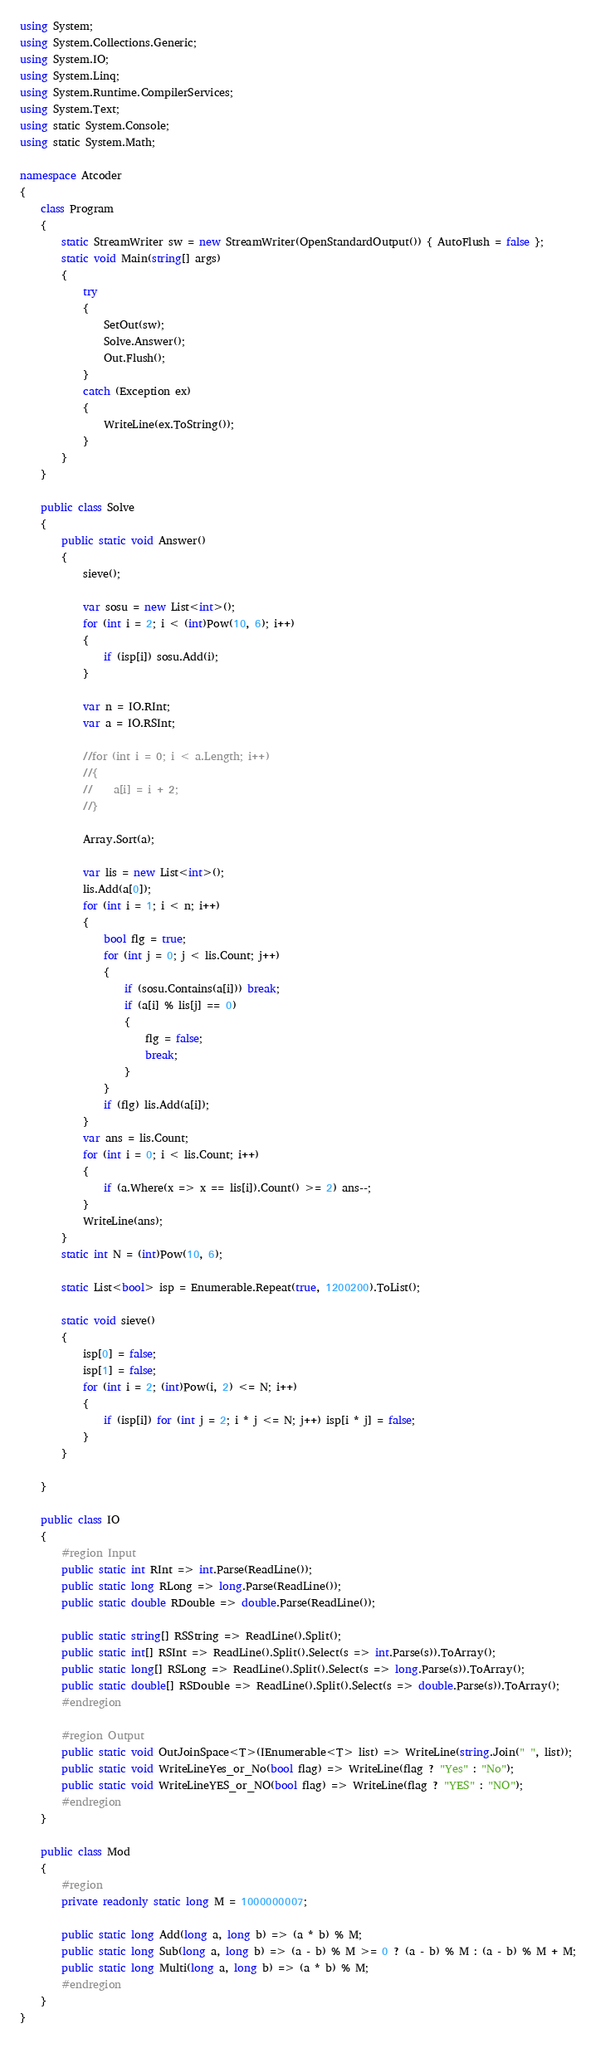<code> <loc_0><loc_0><loc_500><loc_500><_C#_>using System;
using System.Collections.Generic;
using System.IO;
using System.Linq;
using System.Runtime.CompilerServices;
using System.Text;
using static System.Console;
using static System.Math;

namespace Atcoder
{
    class Program
    {
        static StreamWriter sw = new StreamWriter(OpenStandardOutput()) { AutoFlush = false };
        static void Main(string[] args)
        {
            try
            {
                SetOut(sw);
                Solve.Answer();
                Out.Flush();
            }
            catch (Exception ex)
            {
                WriteLine(ex.ToString());
            }
        }
    }

    public class Solve
    {
        public static void Answer()
        {
            sieve();

            var sosu = new List<int>();
            for (int i = 2; i < (int)Pow(10, 6); i++)
            {
                if (isp[i]) sosu.Add(i);
            }

            var n = IO.RInt;
            var a = IO.RSInt;

            //for (int i = 0; i < a.Length; i++)
            //{
            //    a[i] = i + 2;
            //}

            Array.Sort(a);

            var lis = new List<int>();
            lis.Add(a[0]);
            for (int i = 1; i < n; i++)
            {
                bool flg = true;
                for (int j = 0; j < lis.Count; j++)
                {
                    if (sosu.Contains(a[i])) break;
                    if (a[i] % lis[j] == 0)
                    {
                        flg = false;
                        break;
                    }
                }
                if (flg) lis.Add(a[i]);
            }
            var ans = lis.Count;
            for (int i = 0; i < lis.Count; i++)
            {
                if (a.Where(x => x == lis[i]).Count() >= 2) ans--;
            }
            WriteLine(ans);
        }
        static int N = (int)Pow(10, 6);

        static List<bool> isp = Enumerable.Repeat(true, 1200200).ToList();

        static void sieve()
        {
            isp[0] = false;
            isp[1] = false;
            for (int i = 2; (int)Pow(i, 2) <= N; i++)
            {
                if (isp[i]) for (int j = 2; i * j <= N; j++) isp[i * j] = false;
            }
        }

    }

    public class IO
    {
        #region Input
        public static int RInt => int.Parse(ReadLine());
        public static long RLong => long.Parse(ReadLine());
        public static double RDouble => double.Parse(ReadLine());

        public static string[] RSString => ReadLine().Split();
        public static int[] RSInt => ReadLine().Split().Select(s => int.Parse(s)).ToArray();
        public static long[] RSLong => ReadLine().Split().Select(s => long.Parse(s)).ToArray();
        public static double[] RSDouble => ReadLine().Split().Select(s => double.Parse(s)).ToArray();
        #endregion

        #region Output
        public static void OutJoinSpace<T>(IEnumerable<T> list) => WriteLine(string.Join(" ", list));
        public static void WriteLineYes_or_No(bool flag) => WriteLine(flag ? "Yes" : "No");
        public static void WriteLineYES_or_NO(bool flag) => WriteLine(flag ? "YES" : "NO");
        #endregion
    }

    public class Mod
    {
        #region
        private readonly static long M = 1000000007;

        public static long Add(long a, long b) => (a * b) % M;
        public static long Sub(long a, long b) => (a - b) % M >= 0 ? (a - b) % M : (a - b) % M + M;
        public static long Multi(long a, long b) => (a * b) % M;
        #endregion
    }
}</code> 